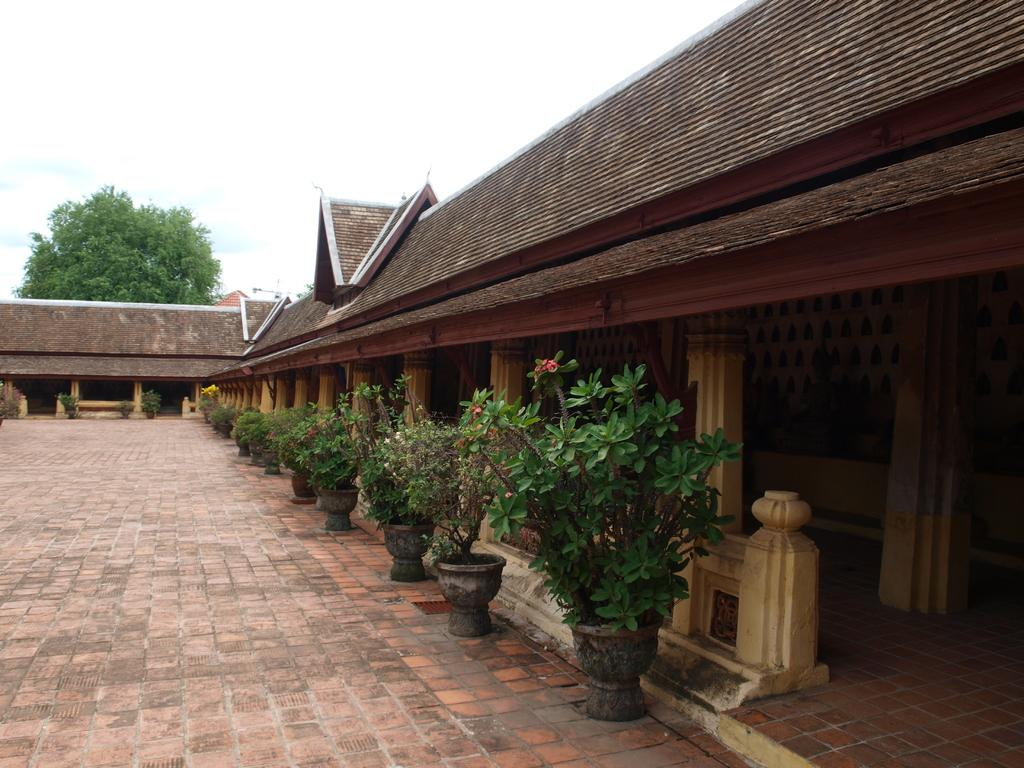What can be seen on the path in the image? There are flower pots on the path in the image. What architectural features are present in the image? There are pillars in the image. What type of objects can be seen inside a house in the image? There are wooden objects in a house in the image. What type of vegetation is visible in the image? There is a tree visible in the image. What is visible above the scene in the image? The sky is visible in the image. What type of chin can be seen on the tree in the image? There is no chin present on the tree in the image; it is a tree with branches and leaves. What type of scarf is draped over the pillars in the image? There is no scarf present on the pillars in the image; they are standing alone without any additional decorations. 